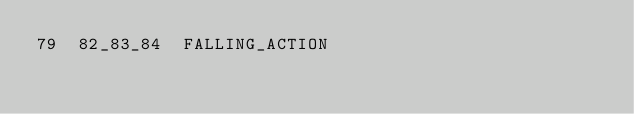<code> <loc_0><loc_0><loc_500><loc_500><_SQL_>79	82_83_84	FALLING_ACTION
</code> 